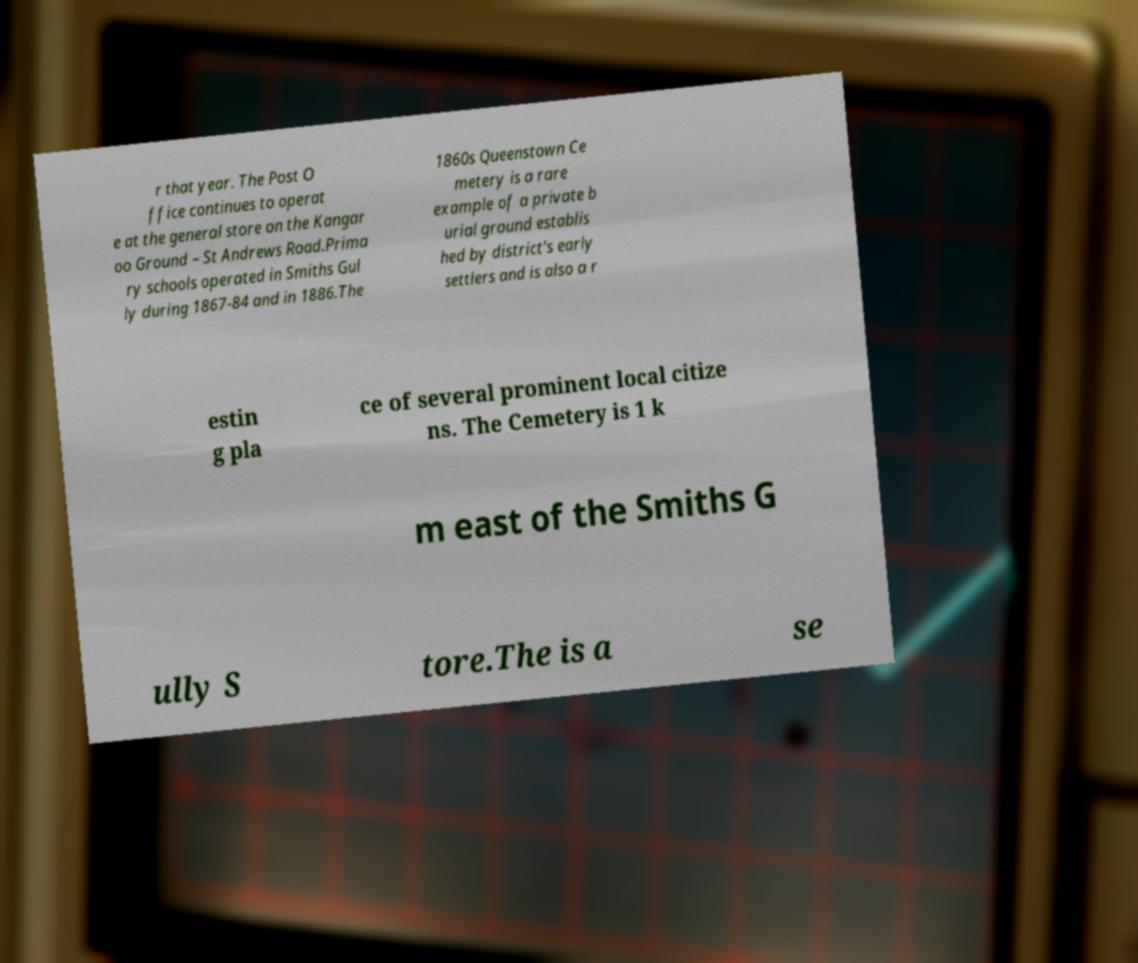Can you read and provide the text displayed in the image?This photo seems to have some interesting text. Can you extract and type it out for me? r that year. The Post O ffice continues to operat e at the general store on the Kangar oo Ground – St Andrews Road.Prima ry schools operated in Smiths Gul ly during 1867-84 and in 1886.The 1860s Queenstown Ce metery is a rare example of a private b urial ground establis hed by district's early settlers and is also a r estin g pla ce of several prominent local citize ns. The Cemetery is 1 k m east of the Smiths G ully S tore.The is a se 